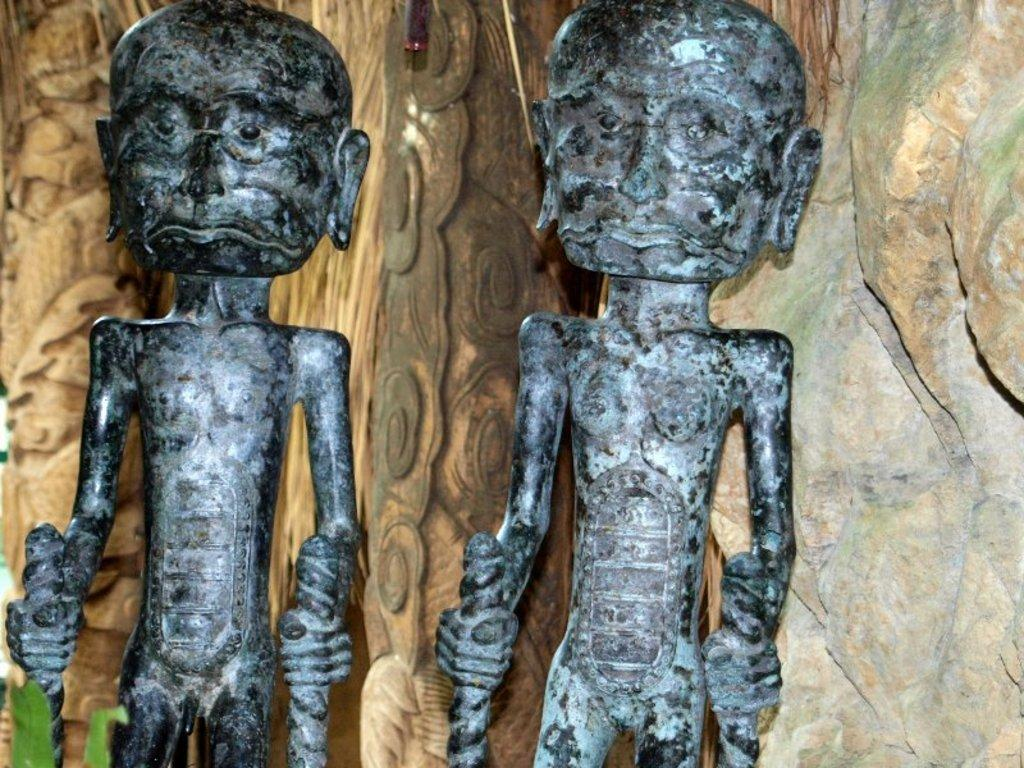What are the main subjects in the image? There are two statues of persons in the image. What can be observed about the background of the image? The background of the image is cream-colored. How many snakes are coiled around the statues in the image? There are no snakes present in the image; it features two statues of persons. What type of shake is being prepared in the image? There is no shake being prepared in the image; it only contains two statues of persons and a cream-colored background. 